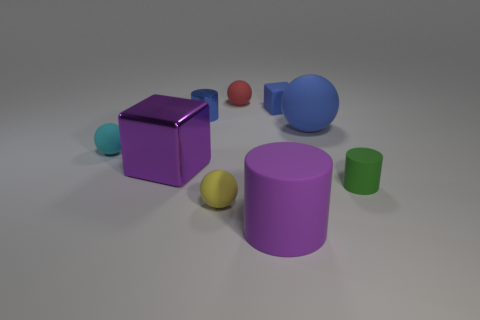Which object appears to be the largest and what texture does it have? The object that appears to be the largest in the image is the blue cylinder. It has a rubber texture that distinguishes it from the metallic sheen of the purple cube or the matte finish of the smaller spheres and cylinders. How does the lighting affect the appearance of these objects? The lighting in the image casts soft shadows and highlights the textures of the objects. It gives the metallic cube a reflective quality, emphasizes the matte surfaces of the colored spheres and cylinders, and gives the rubber objects, especially the large blue one, a slightly shiny finish without a strong reflection. 